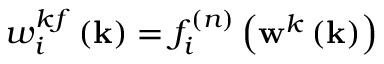Convert formula to latex. <formula><loc_0><loc_0><loc_500><loc_500>w _ { i } ^ { k f } \left ( k \right ) = f _ { i } ^ { ( n ) } \left ( w ^ { k } \left ( k \right ) \right )</formula> 